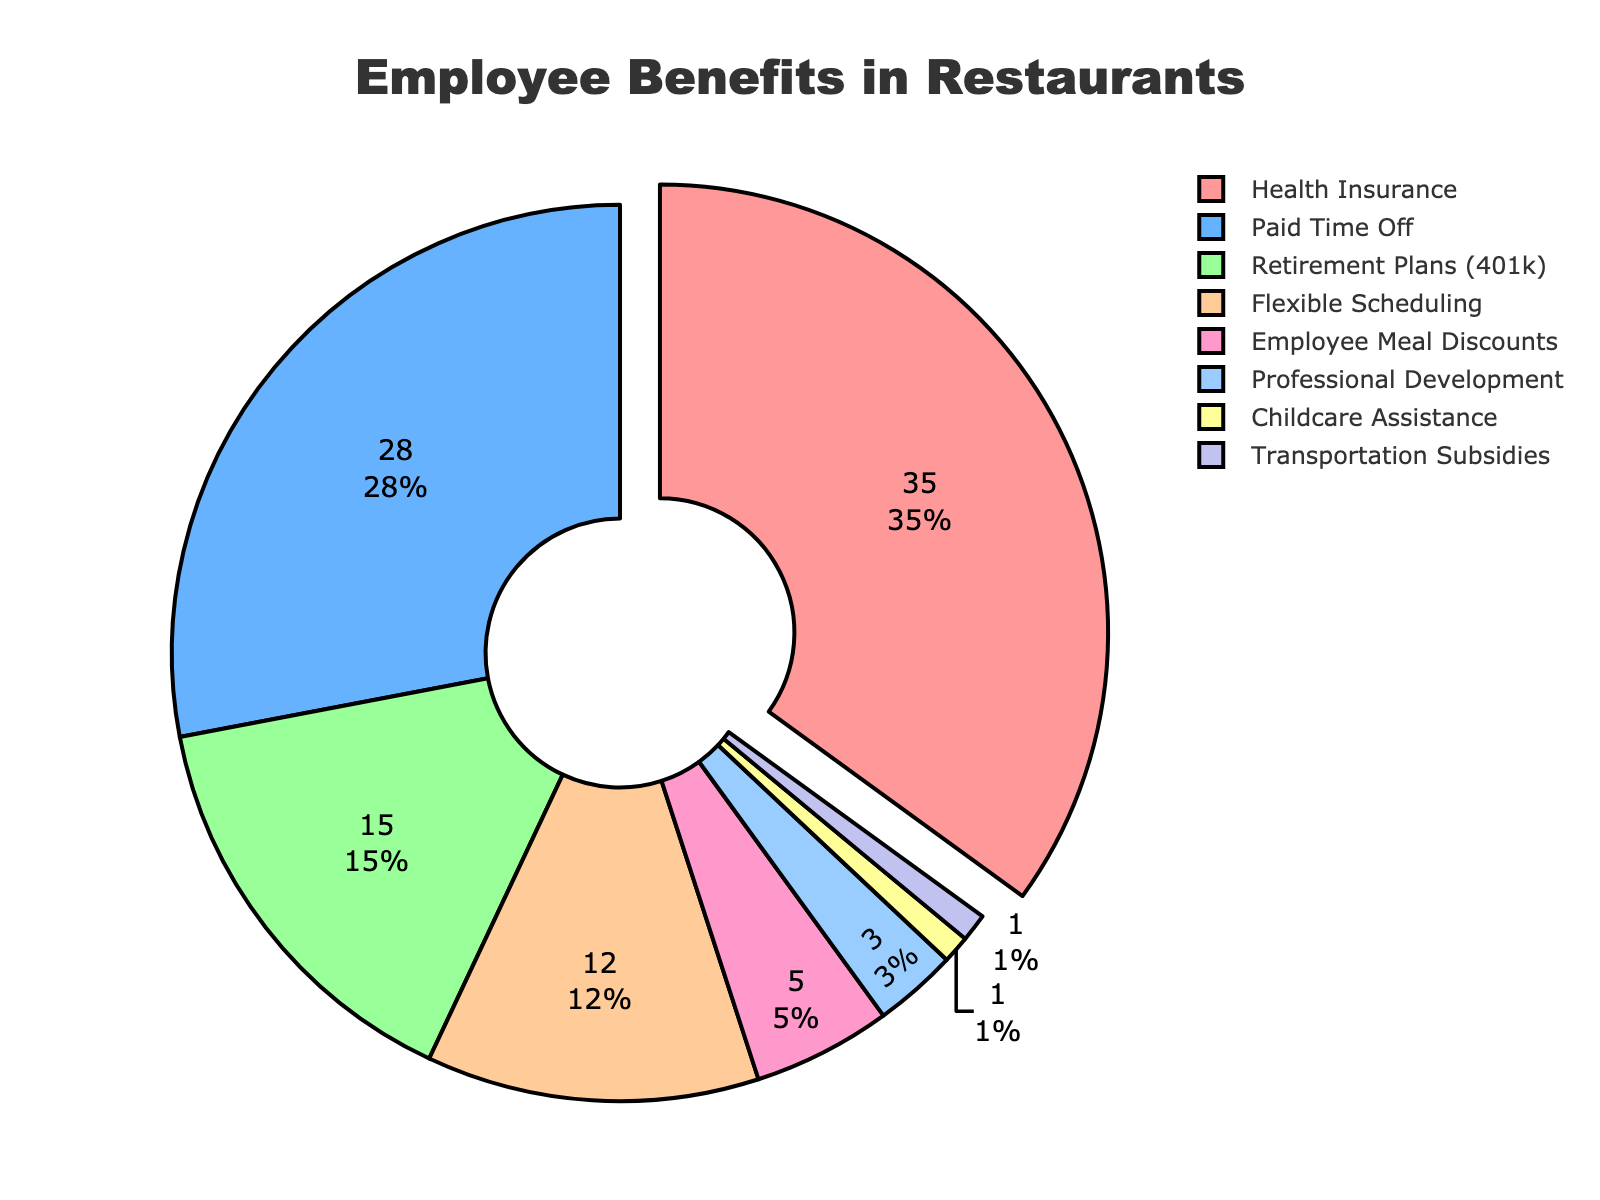Which benefit type is offered by the largest proportion of restaurants? The section with the largest percentage in the pie chart is labeled "Health Insurance". Therefore, Health Insurance is offered by the largest proportion of restaurants.
Answer: Health Insurance What percentage of restaurants offer Paid Time Off and Retirement Plans combined? According to the pie chart, the percentage of restaurants offering Paid Time Off is 28%, and those offering Retirement Plans (401k) is 15%. Adding these together gives 28% + 15% = 43%.
Answer: 43% Which two benefit types have equal proportions in the pie chart? By examining the pie chart, both Childcare Assistance and Transportation Subsidies are labeled with 1%. Thus, these two benefits have equal proportions.
Answer: Childcare Assistance, Transportation Subsidies Is the percentage of restaurants offering Flexible Scheduling greater or less than those offering Employee Meal Discounts? The pie chart indicates that Flexible Scheduling is offered by 12% of restaurants, whereas Employee Meal Discounts are offered by 5%. Since 12% is greater than 5%, Flexible Scheduling is offered by a greater proportion.
Answer: Greater How much larger is the proportion of restaurants offering Health Insurance compared to those offering Employee Meal Discounts? The pie chart shows that Health Insurance is offered by 35% of restaurants while Employee Meal Discounts are offered by 5%. The difference is 35% - 5% = 30%.
Answer: 30% Which benefit type occupies the smallest section of the pie chart? The pie chart shows that the smallest sections are labeled "Childcare Assistance" and "Transportation Subsidies," each with 1%.
Answer: Childcare Assistance, Transportation Subsidies What is the average percentage of restaurants offering the four most common benefits? The four most common benefits according to the pie chart are Health Insurance (35%), Paid Time Off (28%), Retirement Plans (15%), and Flexible Scheduling (12%). The average is calculated by summing these percentages and dividing by four: (35% + 28% + 15% + 12%) / 4 = 90% / 4 = 22.5%.
Answer: 22.5% What is the combined contribution of benefits other than Health Insurance and Paid Time Off? First, determine the combined percentage for Health Insurance and Paid Time Off: 35% + 28% = 63%. Then, subtract this sum from 100% to find the combined contribution of other benefits: 100% - 63% = 37%.
Answer: 37% Which color is used to represent Retirement Plans (401k) in the pie chart? The pie chart utilizes distinct colors for each benefit, and Retirement Plans (401k) is represented by one of the sections. Comparing the colors for each segment to the labels, the corresponding color for Retirement Plans (401k) can be identified.
Answer: Blue (as per the given colors list, the third color corresponds to Retirement Plans (401k)) 